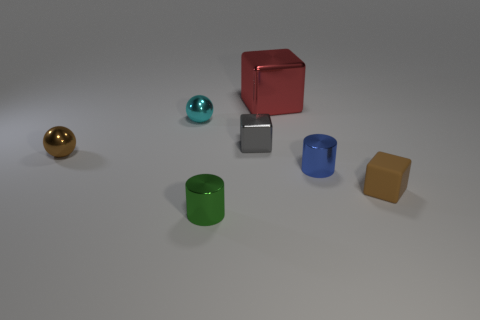Add 2 brown things. How many objects exist? 9 Subtract all cylinders. How many objects are left? 5 Add 4 small blue shiny cylinders. How many small blue shiny cylinders exist? 5 Subtract 0 cyan blocks. How many objects are left? 7 Subtract all brown matte objects. Subtract all cyan spheres. How many objects are left? 5 Add 6 spheres. How many spheres are left? 8 